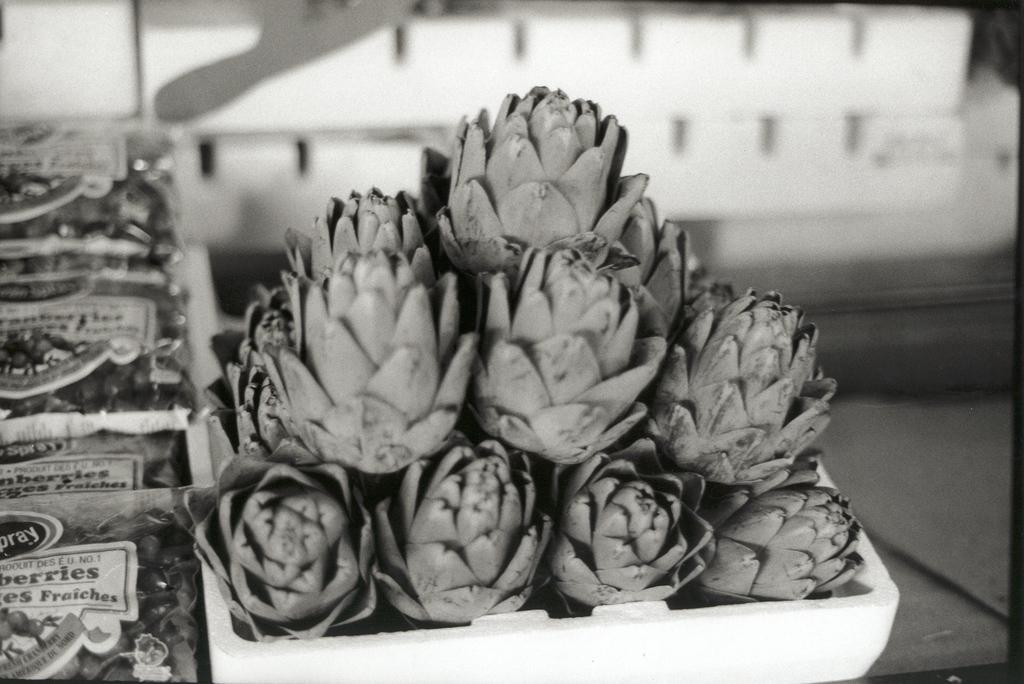What is in the bowl that is visible in the image? There are flowers in a bowl in the image. What else can be seen in the image besides the flowers? There are packets visible in the image. How would you describe the background of the image? The background of the image is blurred. What is the color scheme of the image? The image is in black and white. Can you see a girl wearing a scarf in the image? There is no girl or scarf present in the image; it only features flowers in a bowl, packets, and a blurred background. 